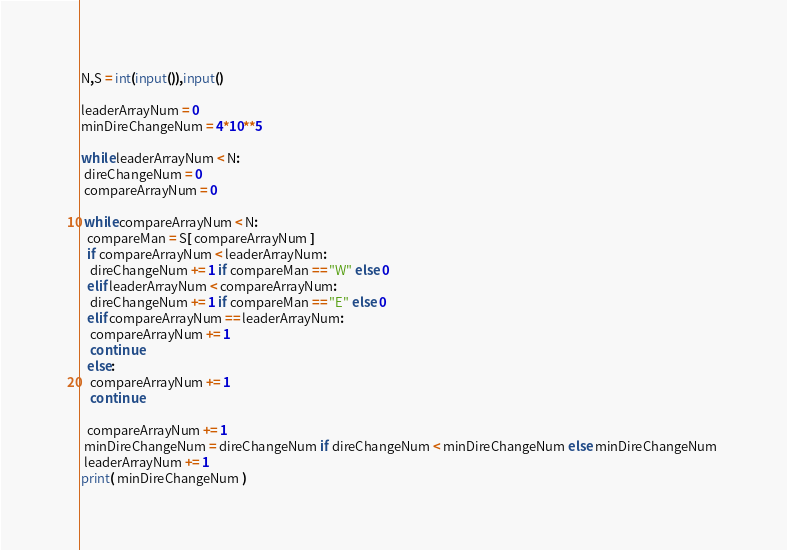<code> <loc_0><loc_0><loc_500><loc_500><_Python_>N,S = int(input()),input()

leaderArrayNum = 0
minDireChangeNum = 4*10**5

while leaderArrayNum < N:
 direChangeNum = 0
 compareArrayNum = 0

 while compareArrayNum < N:
  compareMan = S[ compareArrayNum ]
  if compareArrayNum < leaderArrayNum:
   direChangeNum += 1 if compareMan == "W" else 0  
  elif leaderArrayNum < compareArrayNum:
   direChangeNum += 1 if compareMan == "E" else 0
  elif compareArrayNum == leaderArrayNum:
   compareArrayNum += 1
   continue
  else:
   compareArrayNum += 1
   continue

  compareArrayNum += 1		
 minDireChangeNum = direChangeNum if direChangeNum < minDireChangeNum else minDireChangeNum 
 leaderArrayNum += 1
print( minDireChangeNum )
</code> 